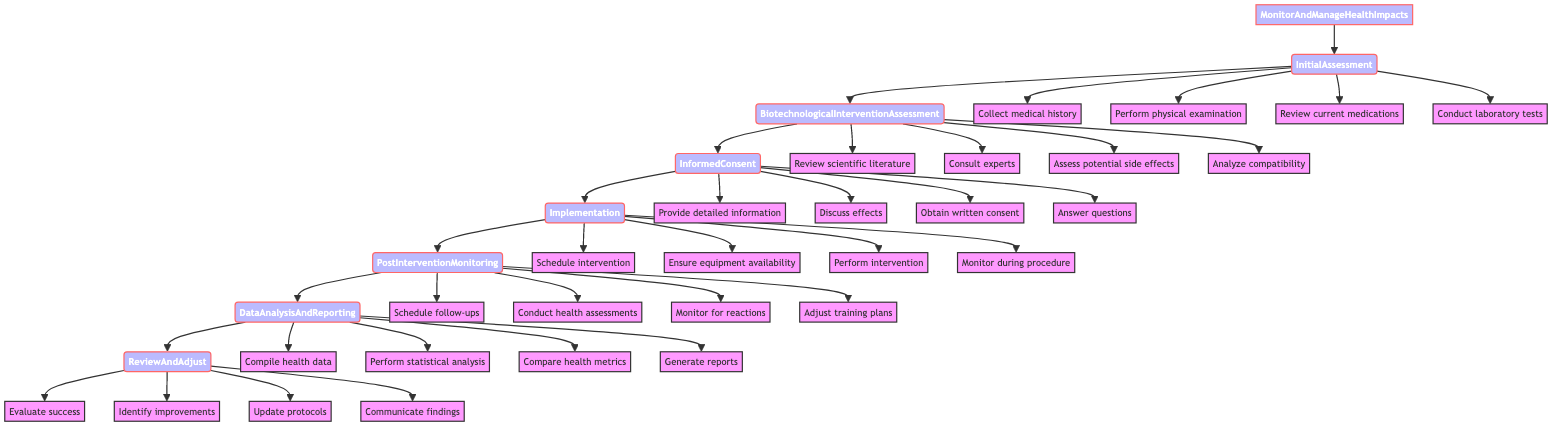What is the first step in the protocol? The diagram indicates that the first step is "InitialAssessment." This is the beginning node in the flowchart from which all subsequent steps branch out.
Answer: InitialAssessment How many actions are listed for the "PostInterventionMonitoring" step? In the flowchart, the "PostInterventionMonitoring" step has four associated actions: scheduling follow-ups, conducting health assessments, monitoring for reactions, and adjusting training plans. Each action is represented as a separate node branching from "PostInterventionMonitoring."
Answer: 4 What step follows "InformedConsent"? The flowchart shows a direct arrow leading from "InformedConsent" to "Implementation." This indicates the sequence of steps, and confirms that the next action after obtaining informed consent is to implement the intervention.
Answer: Implementation Which step involves analyzing compatibility with athlete’s physiology? Looking at the "BiotechnologicalInterventionAssessment" step, one of the actions listed is to "Analyze compatibility with athlete’s physiology." This clearly identifies the focus of this specific step related to the intervention's suitability for the athlete.
Answer: Analyze compatibility with athlete’s physiology What is done during the "DataAnalysisAndReporting" step? The step "DataAnalysisAndReporting" includes multiple actions such as compiling health data, performing statistical analysis, comparing health metrics, and generating reports. These actions demonstrate the comprehensive approach to analyzing collected data and reporting the findings.
Answer: Compile health data, perform statistical analysis, compare health metrics, generate reports Which two steps are directly connected to the "Implementation" step? The flowchart connects "InformedConsent" directly to "Implementation," and follows "Implementation" to "PostInterventionMonitoring." Therefore, the two steps that are directly connected to "Implementation" are "InformedConsent" (previous step) and "PostInterventionMonitoring" (next step).
Answer: InformedConsent, PostInterventionMonitoring What is the last step in the protocol? The last step indicated in the flowchart is "ReviewAndAdjust." It is the final node that follows all other steps in the process, illustrating the conclusion of the monitoring and management protocol.
Answer: ReviewAndAdjust What action is required during "InitialAssessment"? One of the actions required during "InitialAssessment" is to "Collect medical history." This is specified as one of the tasks that need to be performed in the initial evaluation of the athlete's health.
Answer: Collect medical history 